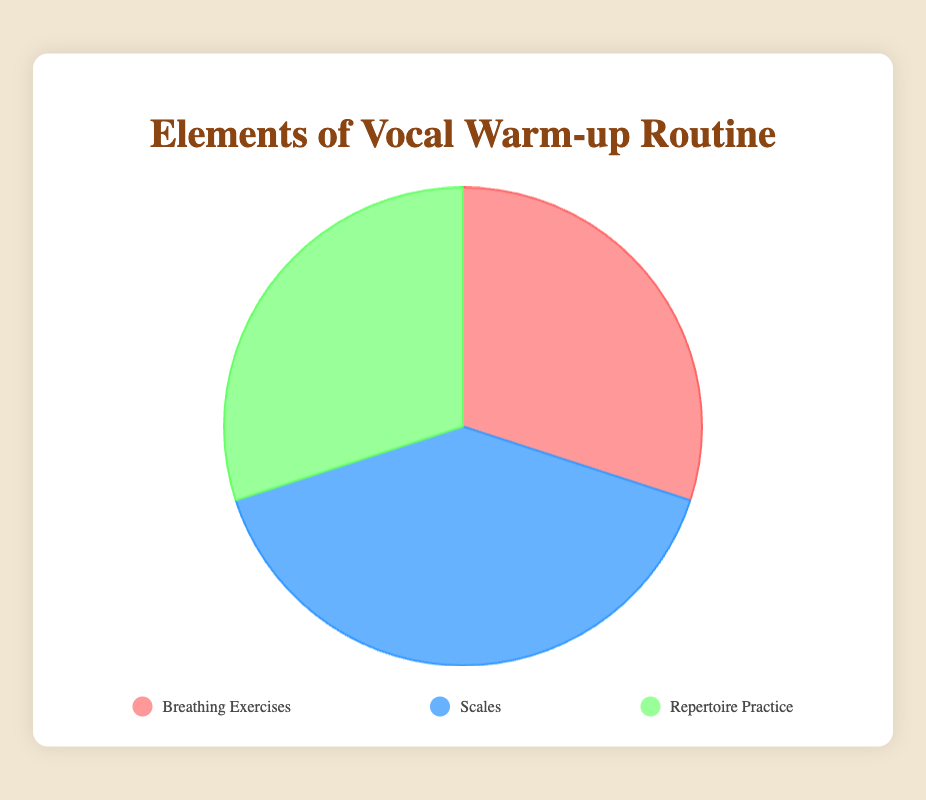What is the largest element in the vocal warm-up routine? To determine the largest element, we look at the data representing the percentages: Breathing Exercises (30%), Scales (40%), and Repertoire Practice (30%). The largest percentage is for Scales.
Answer: Scales Which two elements have the same percentage? Based on the data, both Breathing Exercises and Repertoire Practice each have a percentage of 30%.
Answer: Breathing Exercises and Repertoire Practice What is the total percentage of the vocal warm-up routine devoted to Breathing Exercises and Repertoire Practice combined? Adding the percentages of Breathing Exercises (30%) and Repertoire Practice (30%) gives us 30% + 30% = 60%.
Answer: 60% How does the proportion of Scales compare to Breathing Exercises? Scales (40%) is greater than Breathing Exercises (30%) by 10%.
Answer: 10% greater What color represents the Scales element in the pie chart? In the pie chart, Scales is represented by the color blue.
Answer: Blue If we were to equally divide the percentage of Scales between Breathing Exercises and Repertoire Practice, what would be their new percentages? Scales currently has 40%. Dividing this equally between the two elements gives: 40% / 2 = 20%. Adding this to the current percentages: Breathing Exercises (30% + 20% = 50%) and Repertoire Practice (30% + 20% = 50%).
Answer: 50% each What percentage of the routine is not devoted to practicing scales? The percentage not devoted to Scales is given by 100% - the percentage of Scales (40%), which equals 60%.
Answer: 60% Visualize the split if we combined Breathing Exercises and Repertoire Practice. What proportion would they make compared to Scales? Combining Breathing Exercises (30%) and Repertoire Practice (30%) gives us 30% + 30% = 60%. Compared to Scales (40%), this combined group (60%) is 1.5 times greater.
Answer: 1.5 times greater What element is represented by the red color in the pie chart? Breathing Exercises is represented by the color red in the pie chart.
Answer: Breathing Exercises How much more percentage of the routine is devoted to Scales compared to the smallest element? The smallest elements are Breathing Exercises and Repertoire Practice (both 30%). Scales, at 40%, is 40% - 30% = 10% more than these elements.
Answer: 10% 